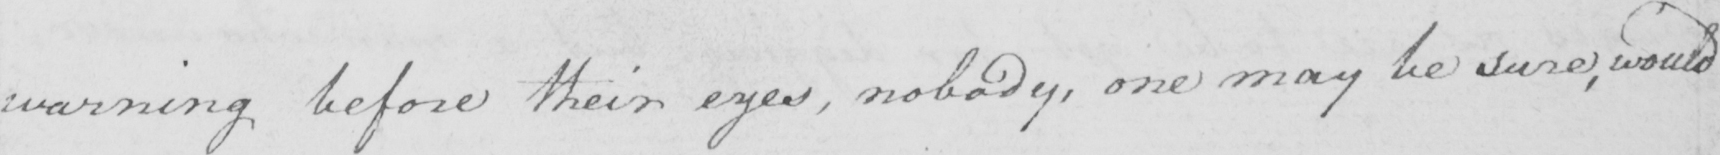What is written in this line of handwriting? warning before their eyes , nobody , one may be sure , would 